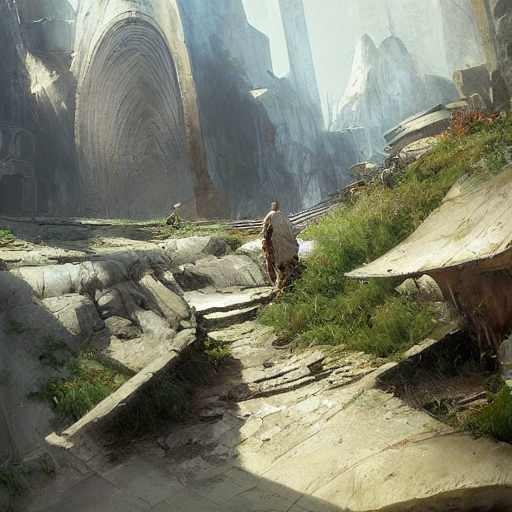What might the person in the image be thinking? While we cannot know the thoughts of the depicted person, one could imagine they're feeling a mix of awe and curiosity, possibly contemplating the history and origins of the ruins they're exploring, or pondering the journey ahead. 